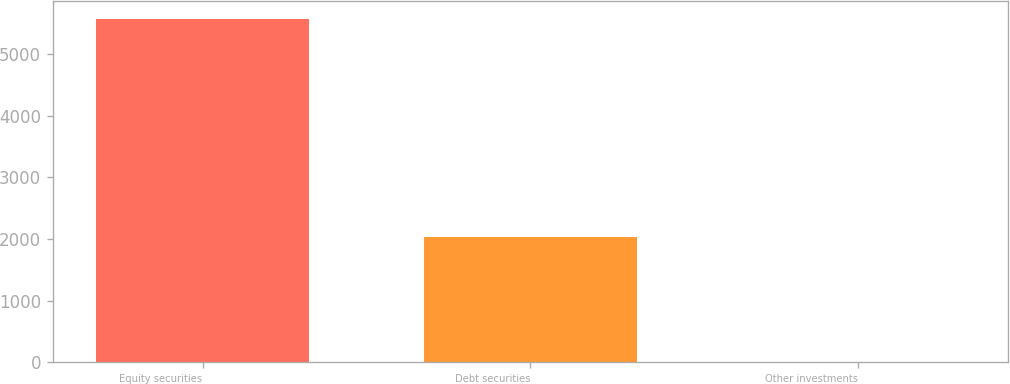Convert chart. <chart><loc_0><loc_0><loc_500><loc_500><bar_chart><fcel>Equity securities<fcel>Debt securities<fcel>Other investments<nl><fcel>5570<fcel>2035<fcel>10<nl></chart> 